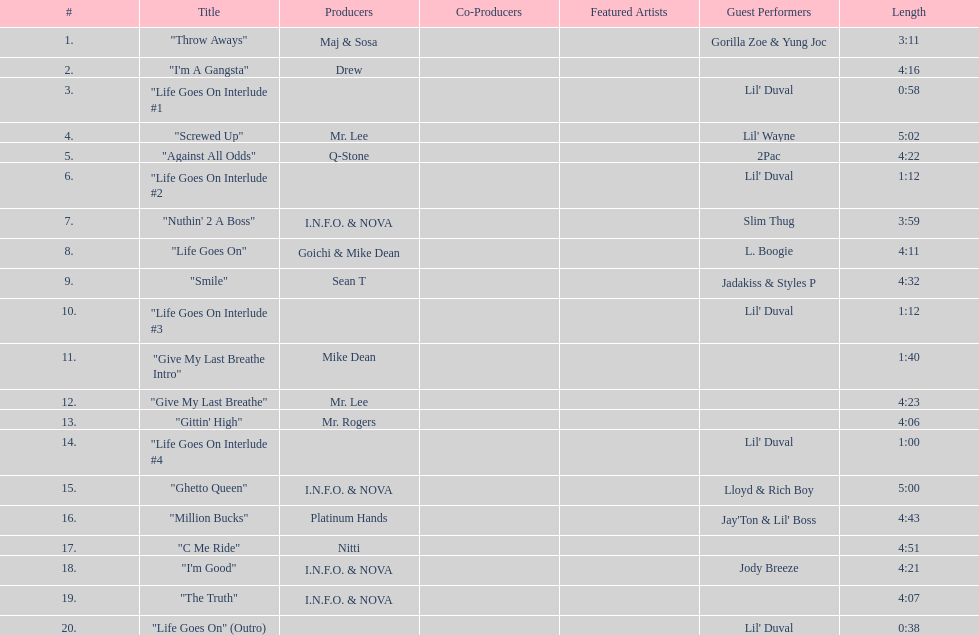What is the first track featuring lil' duval? "Life Goes On Interlude #1. 